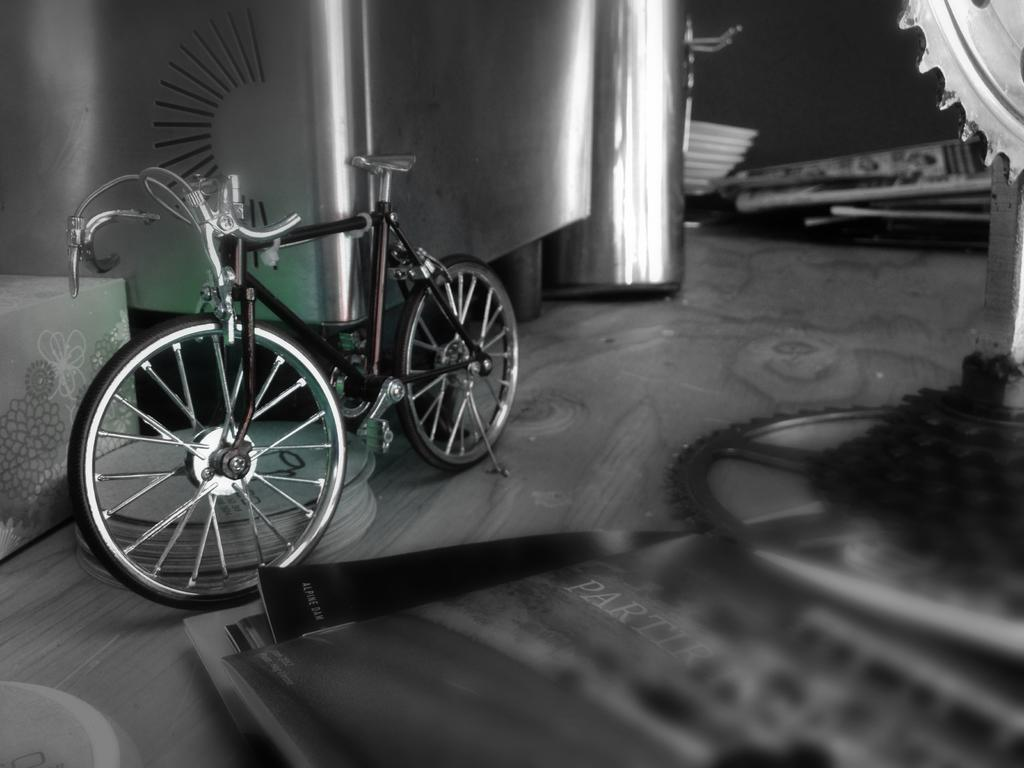What is the main object in the image? There is a bicycle in the image. What else can be seen in the image besides the bicycle? There are books and wheels visible in the image. Are there any objects with a specific color in the image? Yes, there are objects in silver color in the image. What type of class is being taught in the image? There is no class or teaching activity depicted in the image. What kind of produce is being harvested in the image? There is no produce or harvesting activity shown in the image. 